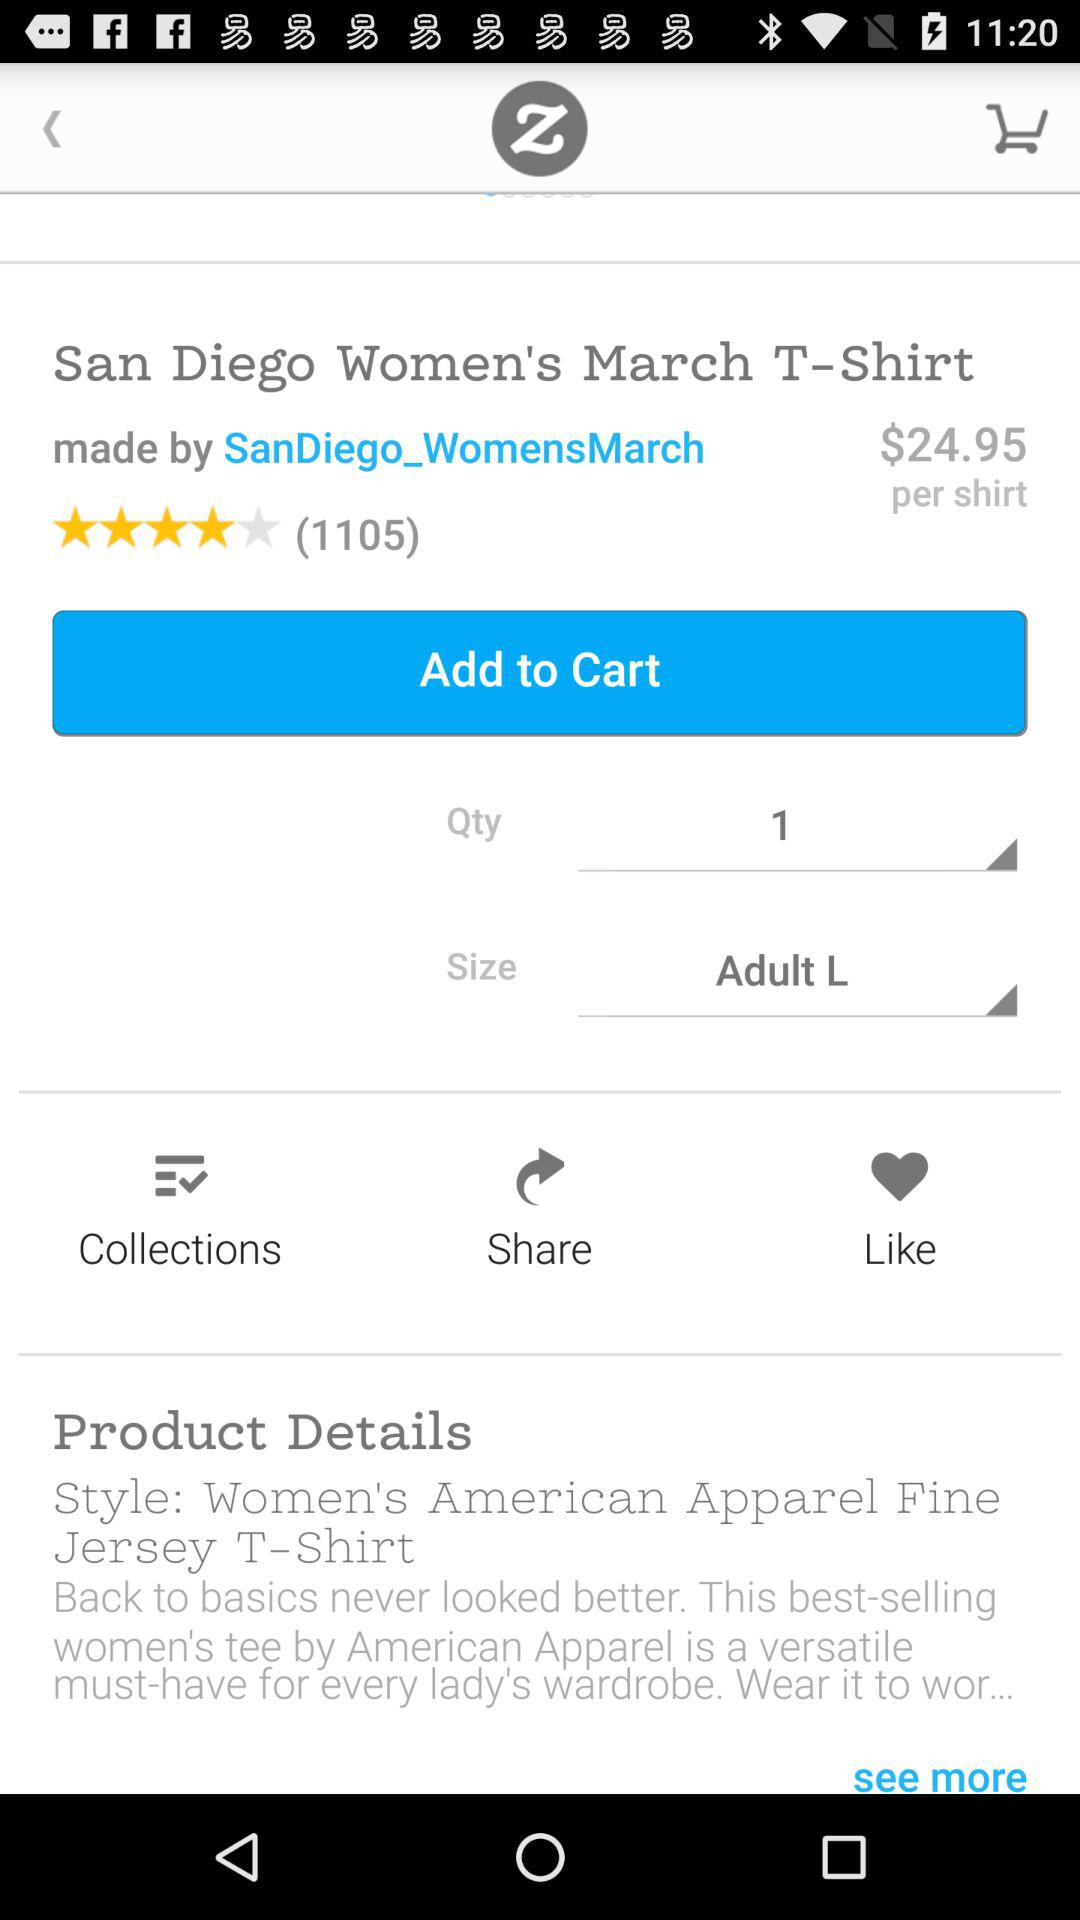How many reviews did the San Diego Women's March T-Shirt got?
When the provided information is insufficient, respond with <no answer>. <no answer> 